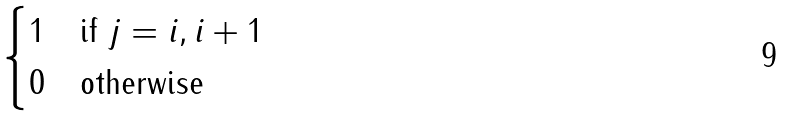<formula> <loc_0><loc_0><loc_500><loc_500>\begin{cases} 1 & \text {if $j=i, i+1$} \\ 0 & \text {otherwise} \end{cases}</formula> 